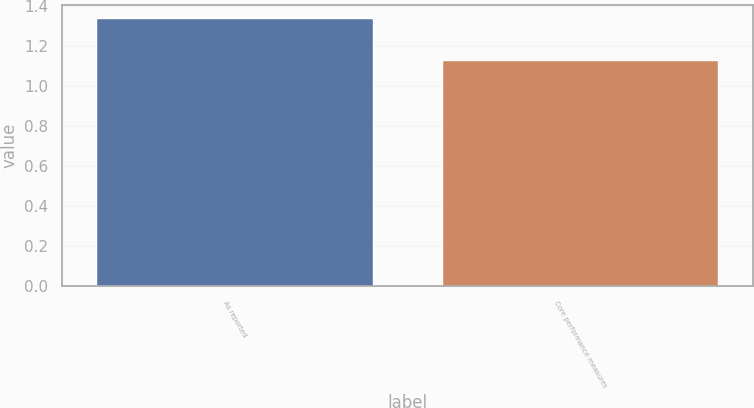Convert chart to OTSL. <chart><loc_0><loc_0><loc_500><loc_500><bar_chart><fcel>As reported<fcel>Core performance measures<nl><fcel>1.34<fcel>1.13<nl></chart> 